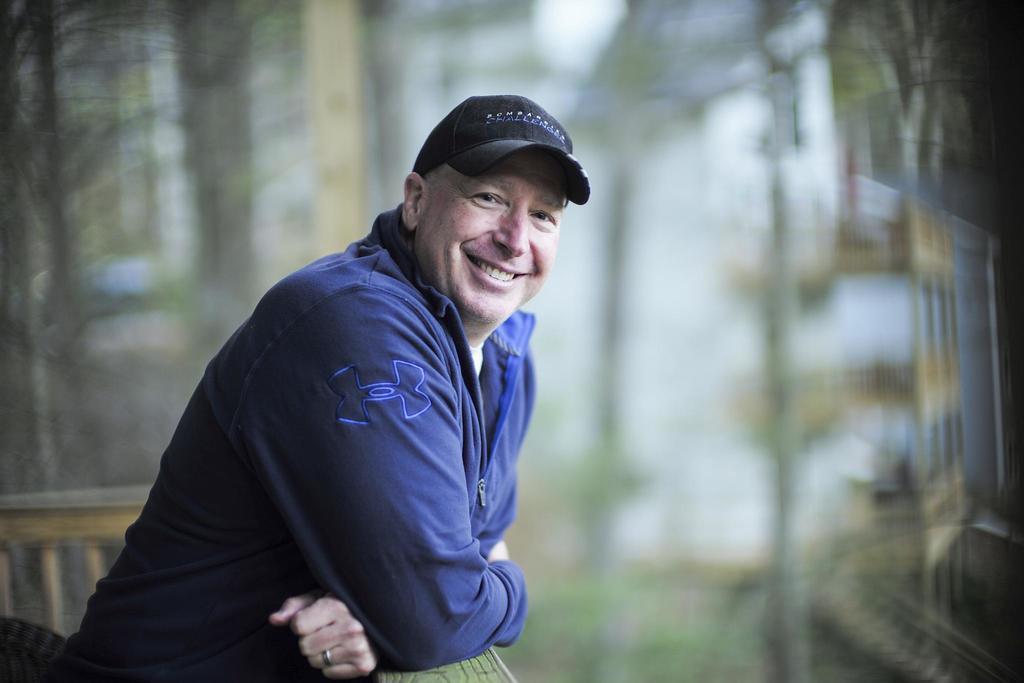Can you describe this image briefly? In this image we can see there is a person standing and there is a fence. And at the back it looks like a blur. 